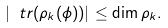<formula> <loc_0><loc_0><loc_500><loc_500>| \ t r ( \rho _ { k } ( \phi ) ) | \leq \dim \rho _ { k } .</formula> 